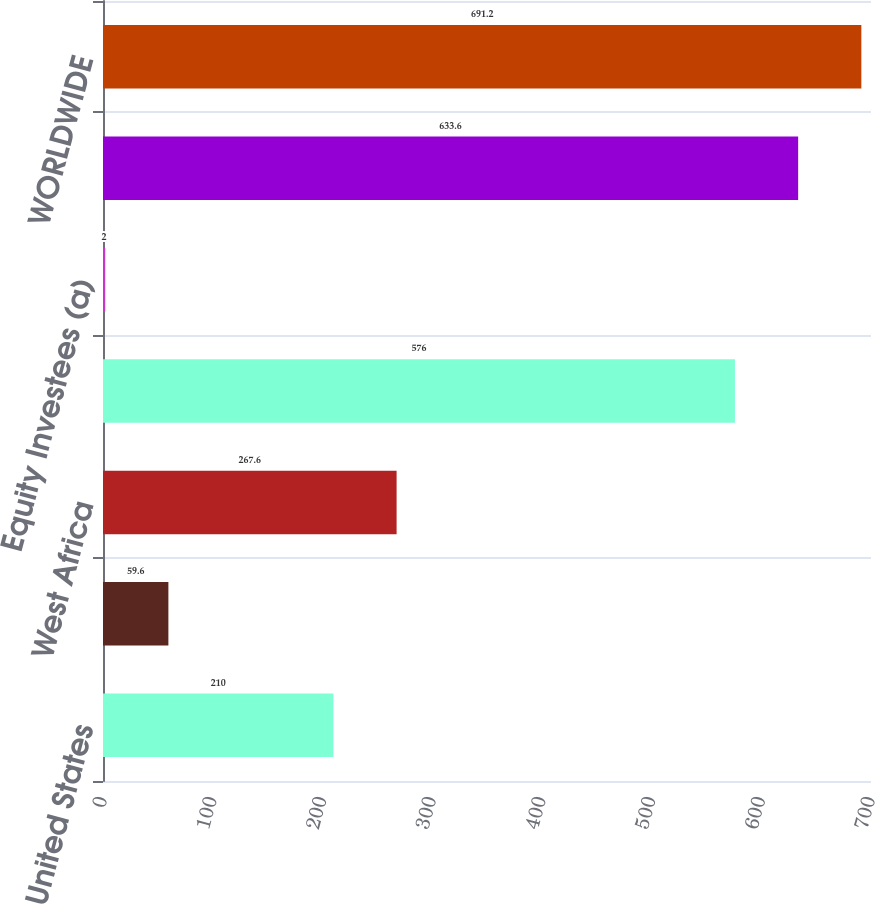Convert chart. <chart><loc_0><loc_0><loc_500><loc_500><bar_chart><fcel>United States<fcel>Europe<fcel>West Africa<fcel>Total Consolidated Continuing<fcel>Equity Investees (a)<fcel>Worldwide Continuing<fcel>WORLDWIDE<nl><fcel>210<fcel>59.6<fcel>267.6<fcel>576<fcel>2<fcel>633.6<fcel>691.2<nl></chart> 